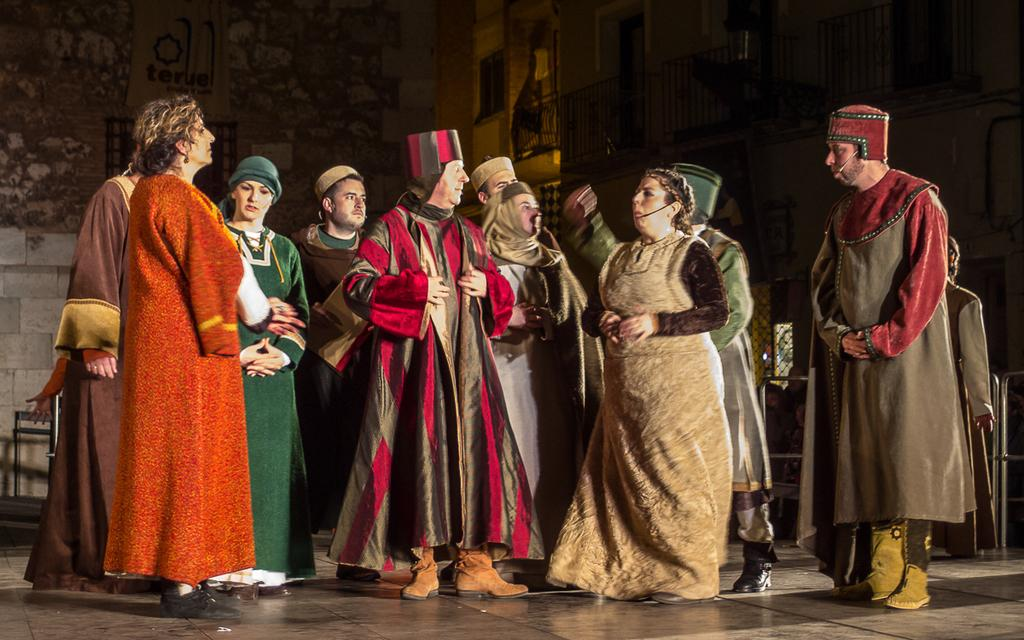What types of people are in the image? There are women and men in the image. What are the people doing in the image? The people are standing. What are the people wearing in the image? They are wearing costumes. What object is present in the image that is typically used for amplifying sound? There is a microphone (mic) in the image. What can be seen in the background of the image? There is a building in the background of the image. What type of loss is being experienced by the men in the image? There is no indication of loss in the image; the people are wearing costumes and standing near a microphone, which suggests they might be participating in an event or performance. 